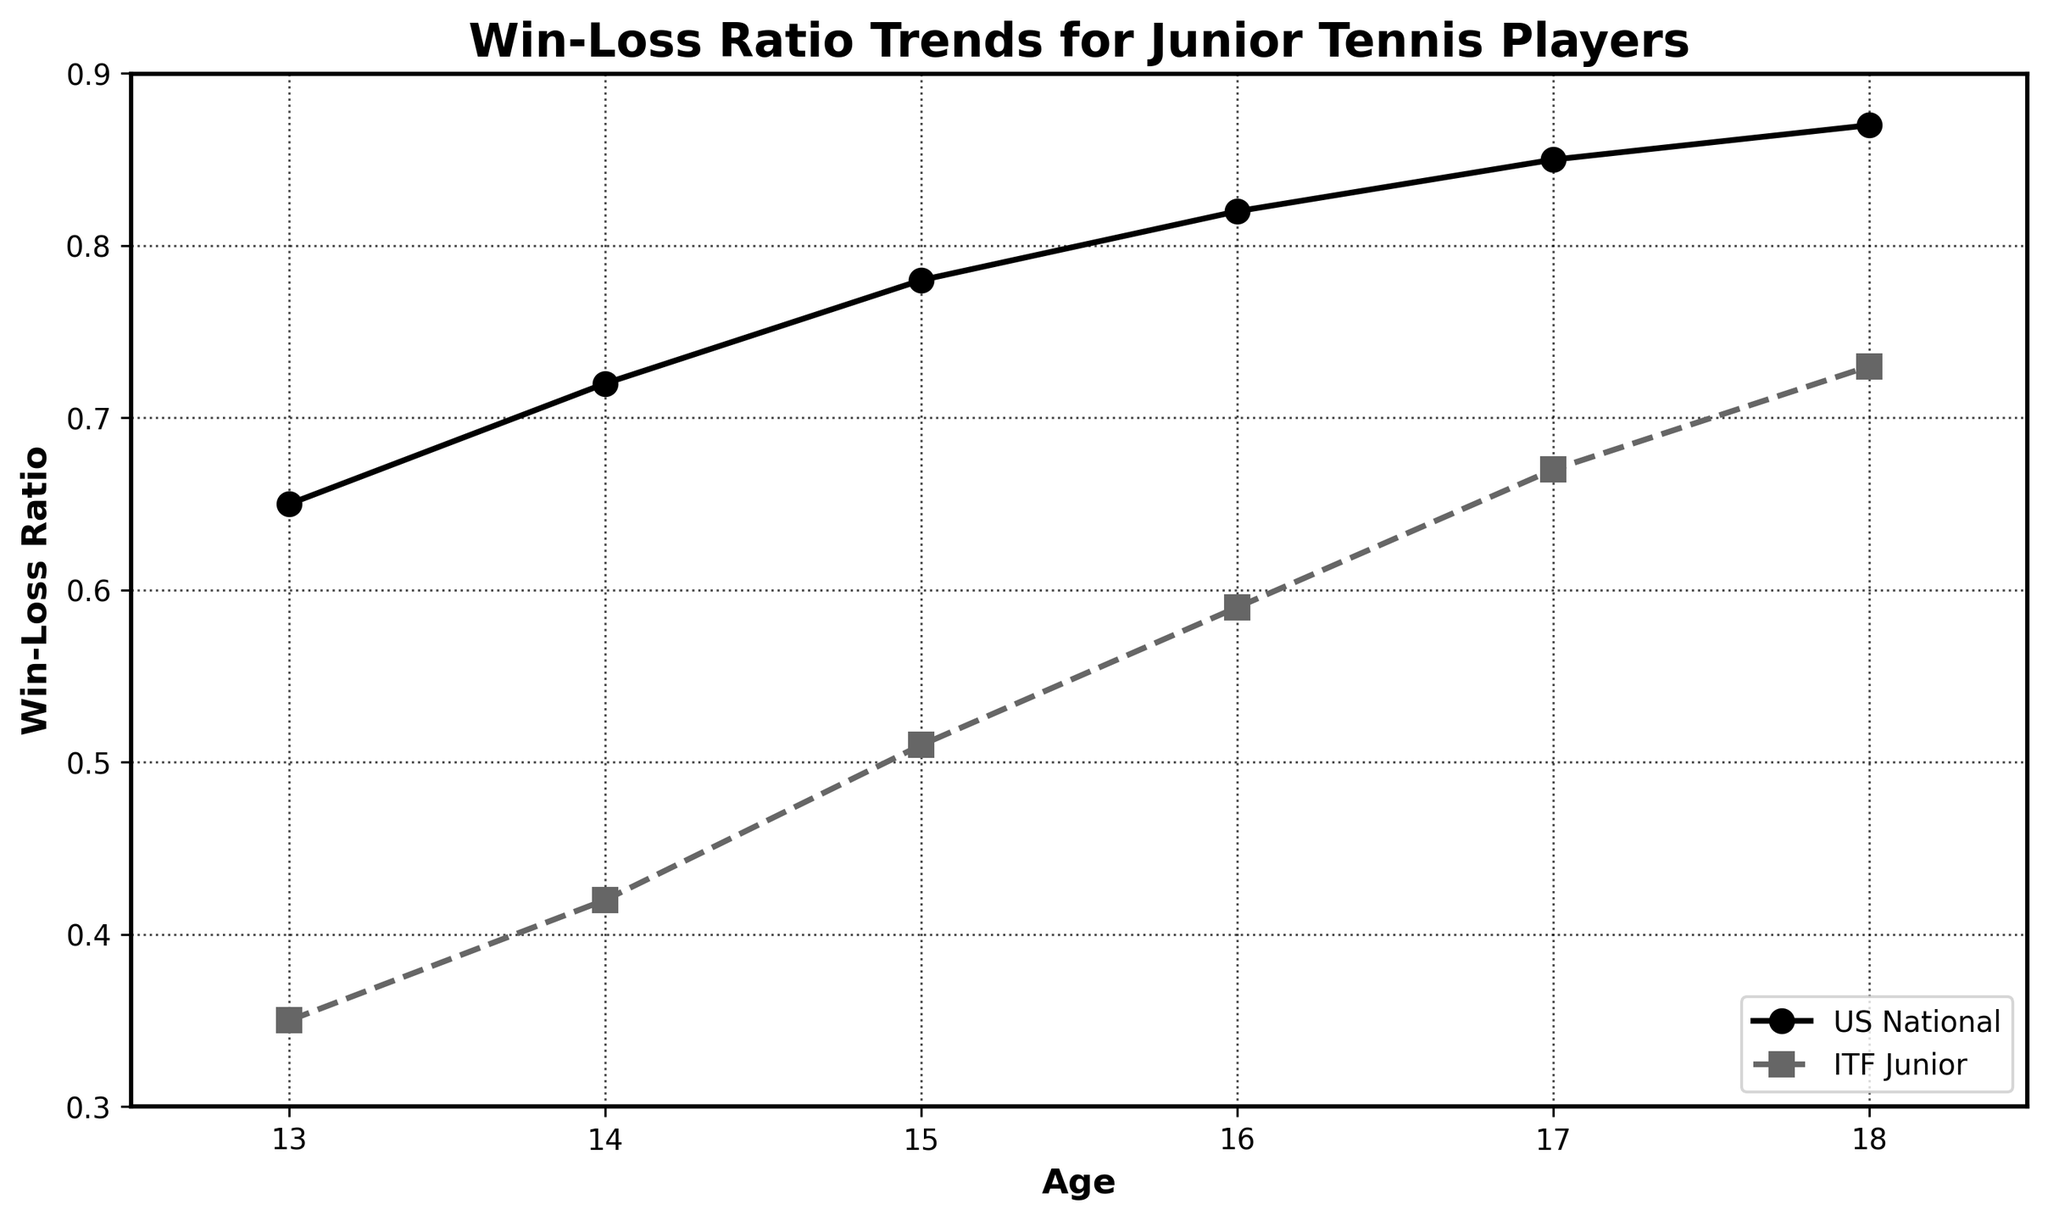What is the win-loss ratio for US National competitions at age 15? By looking at the plotted line for the 'US National' category at age 15, the point on the y-axis indicates the win-loss ratio.
Answer: 0.78 How does the ITF Junior win-loss ratio at age 14 compare to the US National win-loss ratio at the same age? To answer this, observe both plotted lines at age 14. The ITF Junior win-loss ratio is 0.42, whereas the US National win-loss ratio is 0.72.
Answer: ITF Junior is lower What is the difference in win-loss ratio between US National and ITF Junior at age 18? The US National win-loss ratio at age 18 is 0.87 and the ITF Junior win-loss ratio is 0.73. Calculating the difference: 0.87 - 0.73.
Answer: 0.14 How much does the ITF Junior win-loss ratio improve from age 13 to age 18? The win-loss ratio for ITF Junior at age 13 is 0.35, and at age 18 it is 0.73. The difference is 0.73 - 0.35.
Answer: 0.38 At what age does the US National win-loss ratio reach 0.82? By examining the plotted line for 'US National,' the win-loss ratio is 0.82 at age 16.
Answer: 16 Which category shows a higher average win-loss ratio over the ages provided, US National or ITF Junior? Sum and average the win-loss ratios for both categories: US National (0.65 + 0.72 + 0.78 + 0.82 + 0.85 + 0.87) / 6, ITF Junior (0.35 + 0.42 + 0.51 + 0.59 + 0.67 + 0.73) / 6. Compute both averages.
Answer: US National What is the ratio of ITF Junior win-loss at age 16 to US National win-loss at age 14? The ITF Junior win-loss ratio at 16 is 0.59. The US National win-loss ratio at 14 is 0.72. The ratio is 0.59 / 0.72.
Answer: 0.82 Does the win-loss ratio for US National competitions show a linear trend? By analyzing the plotted line for US National, the data points form a consistently increasing pattern. A linear trend means the differences between consecutive points are constant or nearly constant. This line appears linear.
Answer: Yes 